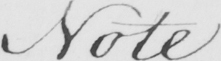What is written in this line of handwriting? Note 